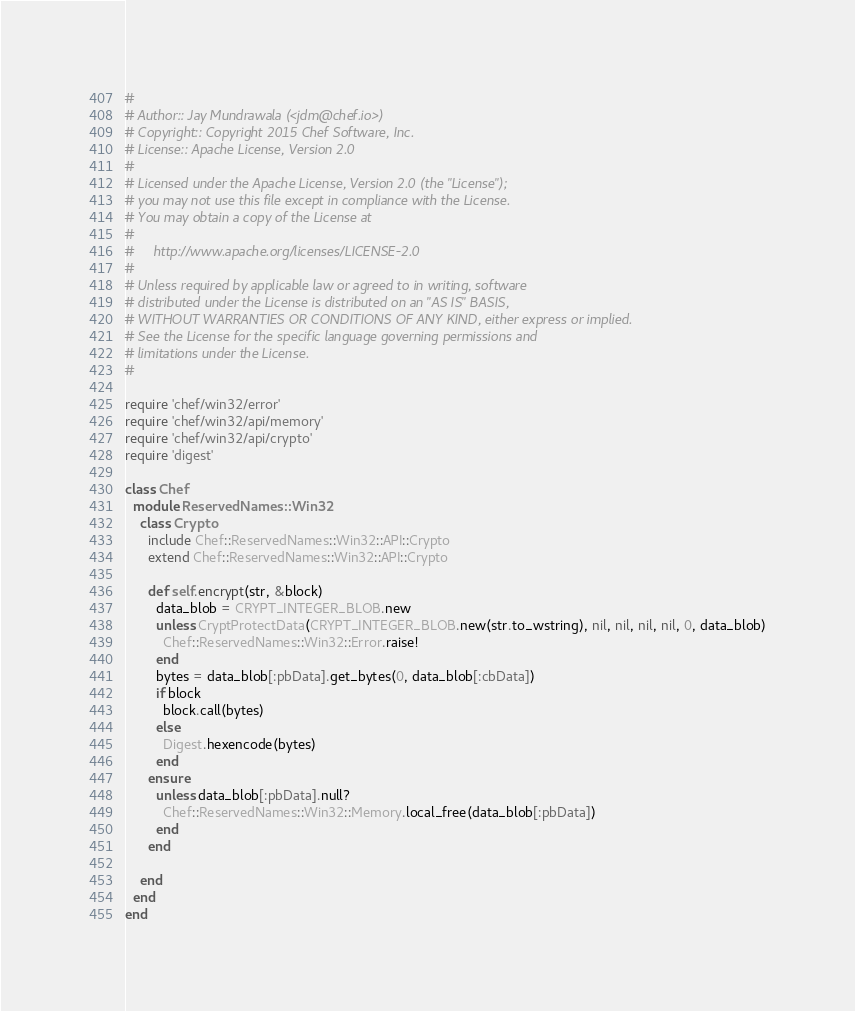<code> <loc_0><loc_0><loc_500><loc_500><_Ruby_>#
# Author:: Jay Mundrawala (<jdm@chef.io>)
# Copyright:: Copyright 2015 Chef Software, Inc.
# License:: Apache License, Version 2.0
#
# Licensed under the Apache License, Version 2.0 (the "License");
# you may not use this file except in compliance with the License.
# You may obtain a copy of the License at
#
#     http://www.apache.org/licenses/LICENSE-2.0
#
# Unless required by applicable law or agreed to in writing, software
# distributed under the License is distributed on an "AS IS" BASIS,
# WITHOUT WARRANTIES OR CONDITIONS OF ANY KIND, either express or implied.
# See the License for the specific language governing permissions and
# limitations under the License.
#

require 'chef/win32/error'
require 'chef/win32/api/memory'
require 'chef/win32/api/crypto'
require 'digest'

class Chef
  module ReservedNames::Win32
    class Crypto
      include Chef::ReservedNames::Win32::API::Crypto
      extend Chef::ReservedNames::Win32::API::Crypto

      def self.encrypt(str, &block)
        data_blob = CRYPT_INTEGER_BLOB.new
        unless CryptProtectData(CRYPT_INTEGER_BLOB.new(str.to_wstring), nil, nil, nil, nil, 0, data_blob)
          Chef::ReservedNames::Win32::Error.raise!
        end
        bytes = data_blob[:pbData].get_bytes(0, data_blob[:cbData])
        if block
          block.call(bytes)
        else
          Digest.hexencode(bytes)
        end
      ensure
        unless data_blob[:pbData].null?
          Chef::ReservedNames::Win32::Memory.local_free(data_blob[:pbData])
        end
      end

    end
  end
end
</code> 